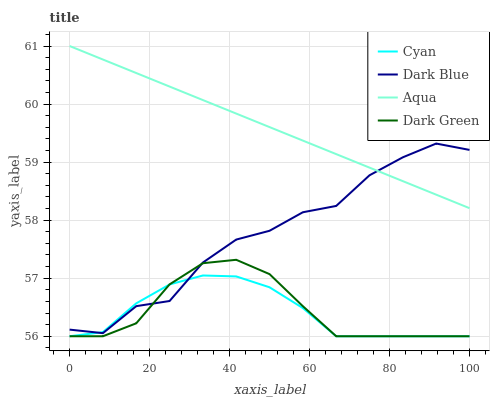Does Cyan have the minimum area under the curve?
Answer yes or no. Yes. Does Aqua have the maximum area under the curve?
Answer yes or no. Yes. Does Dark Green have the minimum area under the curve?
Answer yes or no. No. Does Dark Green have the maximum area under the curve?
Answer yes or no. No. Is Aqua the smoothest?
Answer yes or no. Yes. Is Dark Blue the roughest?
Answer yes or no. Yes. Is Dark Green the smoothest?
Answer yes or no. No. Is Dark Green the roughest?
Answer yes or no. No. Does Aqua have the lowest value?
Answer yes or no. No. Does Dark Green have the highest value?
Answer yes or no. No. Is Cyan less than Aqua?
Answer yes or no. Yes. Is Aqua greater than Cyan?
Answer yes or no. Yes. Does Cyan intersect Aqua?
Answer yes or no. No. 